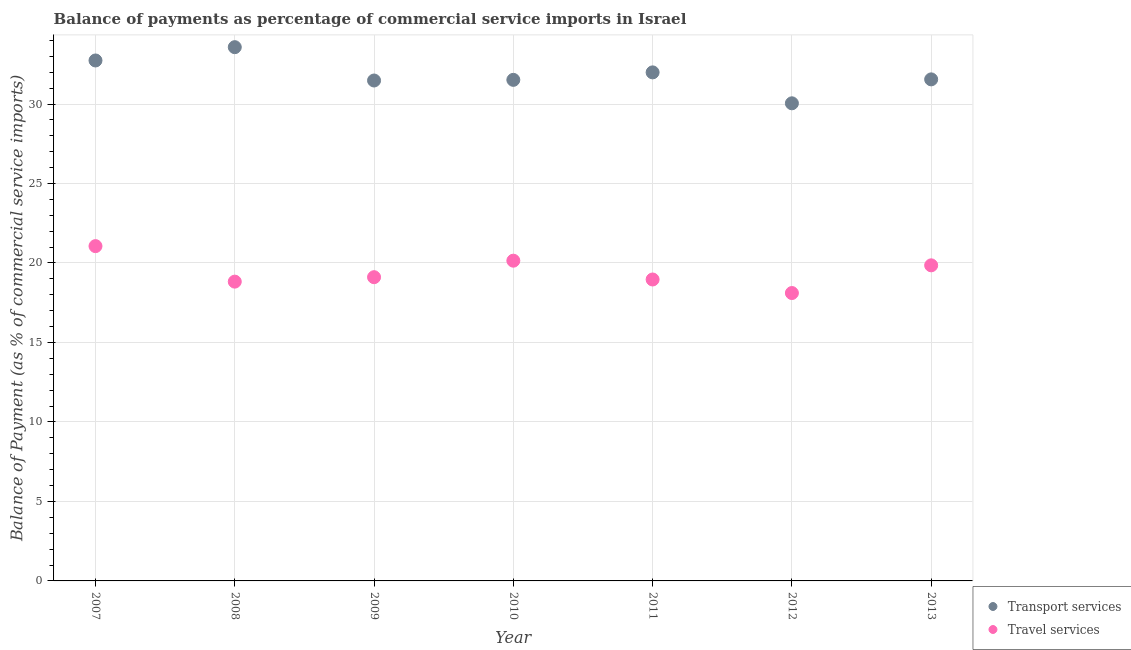Is the number of dotlines equal to the number of legend labels?
Keep it short and to the point. Yes. What is the balance of payments of travel services in 2011?
Make the answer very short. 18.96. Across all years, what is the maximum balance of payments of travel services?
Give a very brief answer. 21.06. Across all years, what is the minimum balance of payments of travel services?
Your answer should be compact. 18.11. In which year was the balance of payments of transport services minimum?
Offer a very short reply. 2012. What is the total balance of payments of travel services in the graph?
Ensure brevity in your answer.  136.06. What is the difference between the balance of payments of transport services in 2007 and that in 2010?
Make the answer very short. 1.22. What is the difference between the balance of payments of travel services in 2012 and the balance of payments of transport services in 2009?
Your answer should be compact. -13.37. What is the average balance of payments of transport services per year?
Offer a terse response. 31.84. In the year 2013, what is the difference between the balance of payments of travel services and balance of payments of transport services?
Keep it short and to the point. -11.7. In how many years, is the balance of payments of travel services greater than 10 %?
Your answer should be very brief. 7. What is the ratio of the balance of payments of transport services in 2012 to that in 2013?
Your answer should be compact. 0.95. Is the balance of payments of travel services in 2010 less than that in 2013?
Your answer should be compact. No. Is the difference between the balance of payments of transport services in 2009 and 2010 greater than the difference between the balance of payments of travel services in 2009 and 2010?
Your response must be concise. Yes. What is the difference between the highest and the second highest balance of payments of travel services?
Offer a terse response. 0.92. What is the difference between the highest and the lowest balance of payments of travel services?
Provide a short and direct response. 2.95. How many dotlines are there?
Ensure brevity in your answer.  2. How many years are there in the graph?
Offer a very short reply. 7. Does the graph contain grids?
Ensure brevity in your answer.  Yes. What is the title of the graph?
Provide a short and direct response. Balance of payments as percentage of commercial service imports in Israel. What is the label or title of the X-axis?
Keep it short and to the point. Year. What is the label or title of the Y-axis?
Your answer should be compact. Balance of Payment (as % of commercial service imports). What is the Balance of Payment (as % of commercial service imports) in Transport services in 2007?
Give a very brief answer. 32.74. What is the Balance of Payment (as % of commercial service imports) of Travel services in 2007?
Offer a terse response. 21.06. What is the Balance of Payment (as % of commercial service imports) in Transport services in 2008?
Make the answer very short. 33.58. What is the Balance of Payment (as % of commercial service imports) in Travel services in 2008?
Your answer should be compact. 18.83. What is the Balance of Payment (as % of commercial service imports) in Transport services in 2009?
Make the answer very short. 31.48. What is the Balance of Payment (as % of commercial service imports) of Travel services in 2009?
Your answer should be very brief. 19.11. What is the Balance of Payment (as % of commercial service imports) of Transport services in 2010?
Your response must be concise. 31.52. What is the Balance of Payment (as % of commercial service imports) of Travel services in 2010?
Your answer should be very brief. 20.14. What is the Balance of Payment (as % of commercial service imports) in Transport services in 2011?
Provide a short and direct response. 31.99. What is the Balance of Payment (as % of commercial service imports) of Travel services in 2011?
Give a very brief answer. 18.96. What is the Balance of Payment (as % of commercial service imports) in Transport services in 2012?
Your response must be concise. 30.04. What is the Balance of Payment (as % of commercial service imports) of Travel services in 2012?
Offer a very short reply. 18.11. What is the Balance of Payment (as % of commercial service imports) in Transport services in 2013?
Your response must be concise. 31.55. What is the Balance of Payment (as % of commercial service imports) in Travel services in 2013?
Your response must be concise. 19.85. Across all years, what is the maximum Balance of Payment (as % of commercial service imports) of Transport services?
Provide a short and direct response. 33.58. Across all years, what is the maximum Balance of Payment (as % of commercial service imports) in Travel services?
Keep it short and to the point. 21.06. Across all years, what is the minimum Balance of Payment (as % of commercial service imports) in Transport services?
Offer a terse response. 30.04. Across all years, what is the minimum Balance of Payment (as % of commercial service imports) in Travel services?
Provide a short and direct response. 18.11. What is the total Balance of Payment (as % of commercial service imports) in Transport services in the graph?
Provide a succinct answer. 222.9. What is the total Balance of Payment (as % of commercial service imports) in Travel services in the graph?
Keep it short and to the point. 136.06. What is the difference between the Balance of Payment (as % of commercial service imports) in Transport services in 2007 and that in 2008?
Ensure brevity in your answer.  -0.84. What is the difference between the Balance of Payment (as % of commercial service imports) of Travel services in 2007 and that in 2008?
Give a very brief answer. 2.23. What is the difference between the Balance of Payment (as % of commercial service imports) of Transport services in 2007 and that in 2009?
Your answer should be very brief. 1.26. What is the difference between the Balance of Payment (as % of commercial service imports) in Travel services in 2007 and that in 2009?
Keep it short and to the point. 1.95. What is the difference between the Balance of Payment (as % of commercial service imports) of Transport services in 2007 and that in 2010?
Offer a very short reply. 1.22. What is the difference between the Balance of Payment (as % of commercial service imports) of Travel services in 2007 and that in 2010?
Offer a very short reply. 0.92. What is the difference between the Balance of Payment (as % of commercial service imports) in Transport services in 2007 and that in 2011?
Offer a terse response. 0.75. What is the difference between the Balance of Payment (as % of commercial service imports) in Travel services in 2007 and that in 2011?
Ensure brevity in your answer.  2.1. What is the difference between the Balance of Payment (as % of commercial service imports) of Transport services in 2007 and that in 2012?
Ensure brevity in your answer.  2.69. What is the difference between the Balance of Payment (as % of commercial service imports) of Travel services in 2007 and that in 2012?
Provide a short and direct response. 2.95. What is the difference between the Balance of Payment (as % of commercial service imports) in Transport services in 2007 and that in 2013?
Provide a succinct answer. 1.19. What is the difference between the Balance of Payment (as % of commercial service imports) in Travel services in 2007 and that in 2013?
Keep it short and to the point. 1.21. What is the difference between the Balance of Payment (as % of commercial service imports) of Transport services in 2008 and that in 2009?
Offer a very short reply. 2.1. What is the difference between the Balance of Payment (as % of commercial service imports) in Travel services in 2008 and that in 2009?
Your response must be concise. -0.28. What is the difference between the Balance of Payment (as % of commercial service imports) in Transport services in 2008 and that in 2010?
Your response must be concise. 2.06. What is the difference between the Balance of Payment (as % of commercial service imports) in Travel services in 2008 and that in 2010?
Provide a short and direct response. -1.32. What is the difference between the Balance of Payment (as % of commercial service imports) of Transport services in 2008 and that in 2011?
Your response must be concise. 1.59. What is the difference between the Balance of Payment (as % of commercial service imports) of Travel services in 2008 and that in 2011?
Keep it short and to the point. -0.14. What is the difference between the Balance of Payment (as % of commercial service imports) in Transport services in 2008 and that in 2012?
Ensure brevity in your answer.  3.53. What is the difference between the Balance of Payment (as % of commercial service imports) of Travel services in 2008 and that in 2012?
Your answer should be very brief. 0.72. What is the difference between the Balance of Payment (as % of commercial service imports) of Transport services in 2008 and that in 2013?
Provide a succinct answer. 2.03. What is the difference between the Balance of Payment (as % of commercial service imports) in Travel services in 2008 and that in 2013?
Your answer should be very brief. -1.02. What is the difference between the Balance of Payment (as % of commercial service imports) in Transport services in 2009 and that in 2010?
Your response must be concise. -0.04. What is the difference between the Balance of Payment (as % of commercial service imports) of Travel services in 2009 and that in 2010?
Provide a succinct answer. -1.04. What is the difference between the Balance of Payment (as % of commercial service imports) of Transport services in 2009 and that in 2011?
Your answer should be very brief. -0.51. What is the difference between the Balance of Payment (as % of commercial service imports) in Travel services in 2009 and that in 2011?
Give a very brief answer. 0.14. What is the difference between the Balance of Payment (as % of commercial service imports) of Transport services in 2009 and that in 2012?
Your answer should be very brief. 1.43. What is the difference between the Balance of Payment (as % of commercial service imports) of Travel services in 2009 and that in 2012?
Ensure brevity in your answer.  1. What is the difference between the Balance of Payment (as % of commercial service imports) in Transport services in 2009 and that in 2013?
Provide a succinct answer. -0.07. What is the difference between the Balance of Payment (as % of commercial service imports) in Travel services in 2009 and that in 2013?
Ensure brevity in your answer.  -0.75. What is the difference between the Balance of Payment (as % of commercial service imports) of Transport services in 2010 and that in 2011?
Your answer should be very brief. -0.47. What is the difference between the Balance of Payment (as % of commercial service imports) of Travel services in 2010 and that in 2011?
Offer a terse response. 1.18. What is the difference between the Balance of Payment (as % of commercial service imports) in Transport services in 2010 and that in 2012?
Make the answer very short. 1.48. What is the difference between the Balance of Payment (as % of commercial service imports) of Travel services in 2010 and that in 2012?
Your answer should be compact. 2.04. What is the difference between the Balance of Payment (as % of commercial service imports) of Transport services in 2010 and that in 2013?
Provide a short and direct response. -0.03. What is the difference between the Balance of Payment (as % of commercial service imports) of Travel services in 2010 and that in 2013?
Your answer should be very brief. 0.29. What is the difference between the Balance of Payment (as % of commercial service imports) in Transport services in 2011 and that in 2012?
Your answer should be compact. 1.95. What is the difference between the Balance of Payment (as % of commercial service imports) of Travel services in 2011 and that in 2012?
Give a very brief answer. 0.85. What is the difference between the Balance of Payment (as % of commercial service imports) in Transport services in 2011 and that in 2013?
Give a very brief answer. 0.44. What is the difference between the Balance of Payment (as % of commercial service imports) of Travel services in 2011 and that in 2013?
Your answer should be compact. -0.89. What is the difference between the Balance of Payment (as % of commercial service imports) in Transport services in 2012 and that in 2013?
Make the answer very short. -1.51. What is the difference between the Balance of Payment (as % of commercial service imports) of Travel services in 2012 and that in 2013?
Your answer should be compact. -1.74. What is the difference between the Balance of Payment (as % of commercial service imports) in Transport services in 2007 and the Balance of Payment (as % of commercial service imports) in Travel services in 2008?
Your answer should be compact. 13.91. What is the difference between the Balance of Payment (as % of commercial service imports) of Transport services in 2007 and the Balance of Payment (as % of commercial service imports) of Travel services in 2009?
Your answer should be compact. 13.63. What is the difference between the Balance of Payment (as % of commercial service imports) of Transport services in 2007 and the Balance of Payment (as % of commercial service imports) of Travel services in 2010?
Make the answer very short. 12.59. What is the difference between the Balance of Payment (as % of commercial service imports) of Transport services in 2007 and the Balance of Payment (as % of commercial service imports) of Travel services in 2011?
Make the answer very short. 13.78. What is the difference between the Balance of Payment (as % of commercial service imports) of Transport services in 2007 and the Balance of Payment (as % of commercial service imports) of Travel services in 2012?
Provide a succinct answer. 14.63. What is the difference between the Balance of Payment (as % of commercial service imports) in Transport services in 2007 and the Balance of Payment (as % of commercial service imports) in Travel services in 2013?
Ensure brevity in your answer.  12.89. What is the difference between the Balance of Payment (as % of commercial service imports) of Transport services in 2008 and the Balance of Payment (as % of commercial service imports) of Travel services in 2009?
Offer a terse response. 14.47. What is the difference between the Balance of Payment (as % of commercial service imports) in Transport services in 2008 and the Balance of Payment (as % of commercial service imports) in Travel services in 2010?
Offer a very short reply. 13.43. What is the difference between the Balance of Payment (as % of commercial service imports) in Transport services in 2008 and the Balance of Payment (as % of commercial service imports) in Travel services in 2011?
Your answer should be very brief. 14.61. What is the difference between the Balance of Payment (as % of commercial service imports) in Transport services in 2008 and the Balance of Payment (as % of commercial service imports) in Travel services in 2012?
Ensure brevity in your answer.  15.47. What is the difference between the Balance of Payment (as % of commercial service imports) in Transport services in 2008 and the Balance of Payment (as % of commercial service imports) in Travel services in 2013?
Your answer should be very brief. 13.72. What is the difference between the Balance of Payment (as % of commercial service imports) of Transport services in 2009 and the Balance of Payment (as % of commercial service imports) of Travel services in 2010?
Your answer should be compact. 11.33. What is the difference between the Balance of Payment (as % of commercial service imports) of Transport services in 2009 and the Balance of Payment (as % of commercial service imports) of Travel services in 2011?
Your answer should be compact. 12.52. What is the difference between the Balance of Payment (as % of commercial service imports) in Transport services in 2009 and the Balance of Payment (as % of commercial service imports) in Travel services in 2012?
Ensure brevity in your answer.  13.37. What is the difference between the Balance of Payment (as % of commercial service imports) in Transport services in 2009 and the Balance of Payment (as % of commercial service imports) in Travel services in 2013?
Provide a succinct answer. 11.63. What is the difference between the Balance of Payment (as % of commercial service imports) of Transport services in 2010 and the Balance of Payment (as % of commercial service imports) of Travel services in 2011?
Provide a short and direct response. 12.56. What is the difference between the Balance of Payment (as % of commercial service imports) in Transport services in 2010 and the Balance of Payment (as % of commercial service imports) in Travel services in 2012?
Make the answer very short. 13.41. What is the difference between the Balance of Payment (as % of commercial service imports) in Transport services in 2010 and the Balance of Payment (as % of commercial service imports) in Travel services in 2013?
Your answer should be very brief. 11.67. What is the difference between the Balance of Payment (as % of commercial service imports) in Transport services in 2011 and the Balance of Payment (as % of commercial service imports) in Travel services in 2012?
Give a very brief answer. 13.88. What is the difference between the Balance of Payment (as % of commercial service imports) in Transport services in 2011 and the Balance of Payment (as % of commercial service imports) in Travel services in 2013?
Your response must be concise. 12.14. What is the difference between the Balance of Payment (as % of commercial service imports) in Transport services in 2012 and the Balance of Payment (as % of commercial service imports) in Travel services in 2013?
Provide a short and direct response. 10.19. What is the average Balance of Payment (as % of commercial service imports) of Transport services per year?
Your answer should be compact. 31.84. What is the average Balance of Payment (as % of commercial service imports) of Travel services per year?
Offer a very short reply. 19.44. In the year 2007, what is the difference between the Balance of Payment (as % of commercial service imports) in Transport services and Balance of Payment (as % of commercial service imports) in Travel services?
Give a very brief answer. 11.68. In the year 2008, what is the difference between the Balance of Payment (as % of commercial service imports) of Transport services and Balance of Payment (as % of commercial service imports) of Travel services?
Provide a short and direct response. 14.75. In the year 2009, what is the difference between the Balance of Payment (as % of commercial service imports) of Transport services and Balance of Payment (as % of commercial service imports) of Travel services?
Your answer should be very brief. 12.37. In the year 2010, what is the difference between the Balance of Payment (as % of commercial service imports) in Transport services and Balance of Payment (as % of commercial service imports) in Travel services?
Provide a succinct answer. 11.38. In the year 2011, what is the difference between the Balance of Payment (as % of commercial service imports) in Transport services and Balance of Payment (as % of commercial service imports) in Travel services?
Offer a terse response. 13.03. In the year 2012, what is the difference between the Balance of Payment (as % of commercial service imports) in Transport services and Balance of Payment (as % of commercial service imports) in Travel services?
Your answer should be very brief. 11.94. In the year 2013, what is the difference between the Balance of Payment (as % of commercial service imports) in Transport services and Balance of Payment (as % of commercial service imports) in Travel services?
Keep it short and to the point. 11.7. What is the ratio of the Balance of Payment (as % of commercial service imports) of Transport services in 2007 to that in 2008?
Offer a terse response. 0.98. What is the ratio of the Balance of Payment (as % of commercial service imports) in Travel services in 2007 to that in 2008?
Keep it short and to the point. 1.12. What is the ratio of the Balance of Payment (as % of commercial service imports) in Travel services in 2007 to that in 2009?
Your answer should be very brief. 1.1. What is the ratio of the Balance of Payment (as % of commercial service imports) in Transport services in 2007 to that in 2010?
Your answer should be compact. 1.04. What is the ratio of the Balance of Payment (as % of commercial service imports) in Travel services in 2007 to that in 2010?
Make the answer very short. 1.05. What is the ratio of the Balance of Payment (as % of commercial service imports) in Transport services in 2007 to that in 2011?
Your answer should be compact. 1.02. What is the ratio of the Balance of Payment (as % of commercial service imports) of Travel services in 2007 to that in 2011?
Your answer should be compact. 1.11. What is the ratio of the Balance of Payment (as % of commercial service imports) in Transport services in 2007 to that in 2012?
Give a very brief answer. 1.09. What is the ratio of the Balance of Payment (as % of commercial service imports) of Travel services in 2007 to that in 2012?
Offer a very short reply. 1.16. What is the ratio of the Balance of Payment (as % of commercial service imports) in Transport services in 2007 to that in 2013?
Provide a succinct answer. 1.04. What is the ratio of the Balance of Payment (as % of commercial service imports) in Travel services in 2007 to that in 2013?
Provide a succinct answer. 1.06. What is the ratio of the Balance of Payment (as % of commercial service imports) in Transport services in 2008 to that in 2009?
Keep it short and to the point. 1.07. What is the ratio of the Balance of Payment (as % of commercial service imports) of Travel services in 2008 to that in 2009?
Give a very brief answer. 0.99. What is the ratio of the Balance of Payment (as % of commercial service imports) in Transport services in 2008 to that in 2010?
Make the answer very short. 1.07. What is the ratio of the Balance of Payment (as % of commercial service imports) of Travel services in 2008 to that in 2010?
Offer a very short reply. 0.93. What is the ratio of the Balance of Payment (as % of commercial service imports) of Transport services in 2008 to that in 2011?
Keep it short and to the point. 1.05. What is the ratio of the Balance of Payment (as % of commercial service imports) of Travel services in 2008 to that in 2011?
Your answer should be compact. 0.99. What is the ratio of the Balance of Payment (as % of commercial service imports) in Transport services in 2008 to that in 2012?
Offer a terse response. 1.12. What is the ratio of the Balance of Payment (as % of commercial service imports) in Travel services in 2008 to that in 2012?
Ensure brevity in your answer.  1.04. What is the ratio of the Balance of Payment (as % of commercial service imports) in Transport services in 2008 to that in 2013?
Your response must be concise. 1.06. What is the ratio of the Balance of Payment (as % of commercial service imports) in Travel services in 2008 to that in 2013?
Provide a succinct answer. 0.95. What is the ratio of the Balance of Payment (as % of commercial service imports) in Travel services in 2009 to that in 2010?
Offer a very short reply. 0.95. What is the ratio of the Balance of Payment (as % of commercial service imports) of Transport services in 2009 to that in 2011?
Offer a terse response. 0.98. What is the ratio of the Balance of Payment (as % of commercial service imports) in Travel services in 2009 to that in 2011?
Provide a short and direct response. 1.01. What is the ratio of the Balance of Payment (as % of commercial service imports) in Transport services in 2009 to that in 2012?
Offer a terse response. 1.05. What is the ratio of the Balance of Payment (as % of commercial service imports) in Travel services in 2009 to that in 2012?
Give a very brief answer. 1.05. What is the ratio of the Balance of Payment (as % of commercial service imports) in Travel services in 2009 to that in 2013?
Ensure brevity in your answer.  0.96. What is the ratio of the Balance of Payment (as % of commercial service imports) in Transport services in 2010 to that in 2011?
Offer a very short reply. 0.99. What is the ratio of the Balance of Payment (as % of commercial service imports) in Travel services in 2010 to that in 2011?
Your response must be concise. 1.06. What is the ratio of the Balance of Payment (as % of commercial service imports) in Transport services in 2010 to that in 2012?
Offer a terse response. 1.05. What is the ratio of the Balance of Payment (as % of commercial service imports) in Travel services in 2010 to that in 2012?
Provide a short and direct response. 1.11. What is the ratio of the Balance of Payment (as % of commercial service imports) in Transport services in 2010 to that in 2013?
Keep it short and to the point. 1. What is the ratio of the Balance of Payment (as % of commercial service imports) in Travel services in 2010 to that in 2013?
Give a very brief answer. 1.01. What is the ratio of the Balance of Payment (as % of commercial service imports) in Transport services in 2011 to that in 2012?
Provide a succinct answer. 1.06. What is the ratio of the Balance of Payment (as % of commercial service imports) of Travel services in 2011 to that in 2012?
Ensure brevity in your answer.  1.05. What is the ratio of the Balance of Payment (as % of commercial service imports) in Transport services in 2011 to that in 2013?
Offer a very short reply. 1.01. What is the ratio of the Balance of Payment (as % of commercial service imports) of Travel services in 2011 to that in 2013?
Provide a succinct answer. 0.96. What is the ratio of the Balance of Payment (as % of commercial service imports) of Transport services in 2012 to that in 2013?
Keep it short and to the point. 0.95. What is the ratio of the Balance of Payment (as % of commercial service imports) in Travel services in 2012 to that in 2013?
Ensure brevity in your answer.  0.91. What is the difference between the highest and the second highest Balance of Payment (as % of commercial service imports) of Transport services?
Your answer should be compact. 0.84. What is the difference between the highest and the second highest Balance of Payment (as % of commercial service imports) in Travel services?
Ensure brevity in your answer.  0.92. What is the difference between the highest and the lowest Balance of Payment (as % of commercial service imports) in Transport services?
Your response must be concise. 3.53. What is the difference between the highest and the lowest Balance of Payment (as % of commercial service imports) of Travel services?
Offer a very short reply. 2.95. 